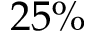<formula> <loc_0><loc_0><loc_500><loc_500>2 5 \%</formula> 